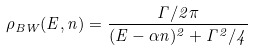<formula> <loc_0><loc_0><loc_500><loc_500>\rho _ { B W } ( E , n ) = \frac { \Gamma / 2 \pi } { ( E - \alpha n ) ^ { 2 } + \Gamma ^ { 2 } / 4 }</formula> 